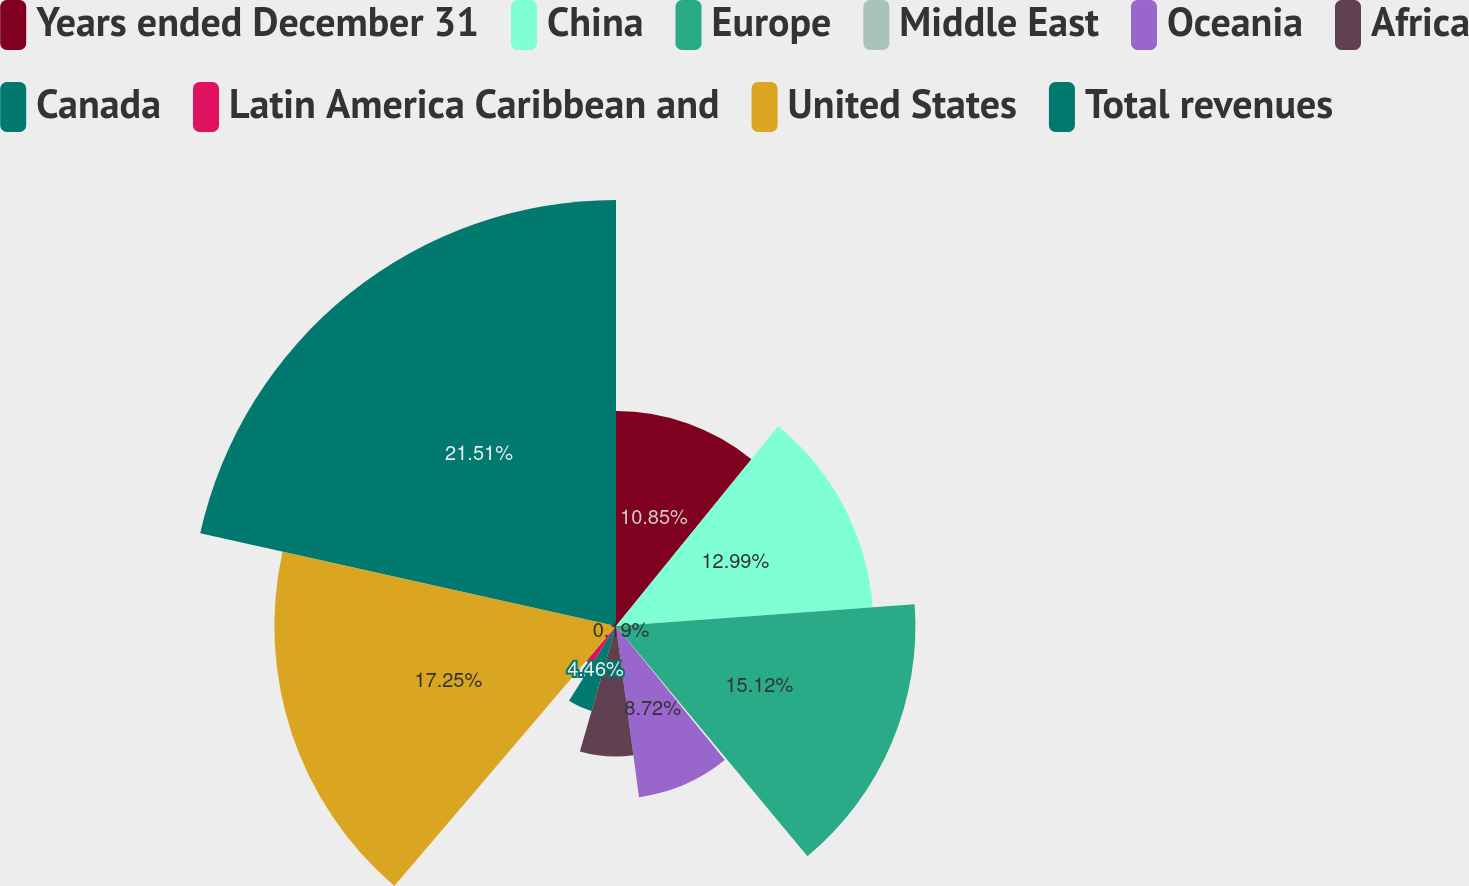Convert chart to OTSL. <chart><loc_0><loc_0><loc_500><loc_500><pie_chart><fcel>Years ended December 31<fcel>China<fcel>Europe<fcel>Middle East<fcel>Oceania<fcel>Africa<fcel>Canada<fcel>Latin America Caribbean and<fcel>United States<fcel>Total revenues<nl><fcel>10.85%<fcel>12.99%<fcel>15.12%<fcel>0.19%<fcel>8.72%<fcel>6.59%<fcel>4.46%<fcel>2.32%<fcel>17.25%<fcel>21.51%<nl></chart> 